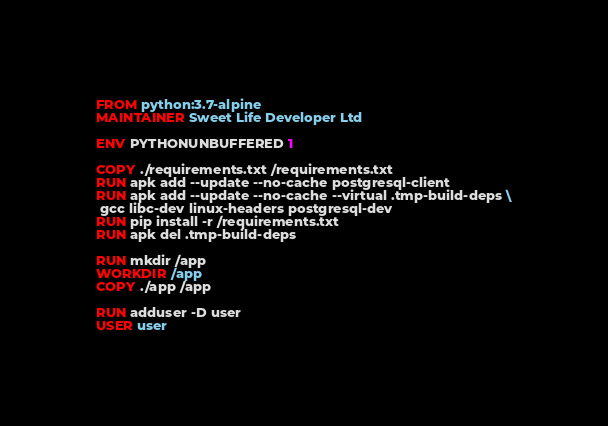<code> <loc_0><loc_0><loc_500><loc_500><_Dockerfile_>FROM python:3.7-alpine
MAINTAINER Sweet Life Developer Ltd

ENV PYTHONUNBUFFERED 1

COPY ./requirements.txt /requirements.txt
RUN apk add --update --no-cache postgresql-client
RUN apk add --update --no-cache --virtual .tmp-build-deps \
 gcc libc-dev linux-headers postgresql-dev
RUN pip install -r /requirements.txt
RUN apk del .tmp-build-deps

RUN mkdir /app
WORKDIR /app
COPY ./app /app

RUN adduser -D user
USER user
</code> 